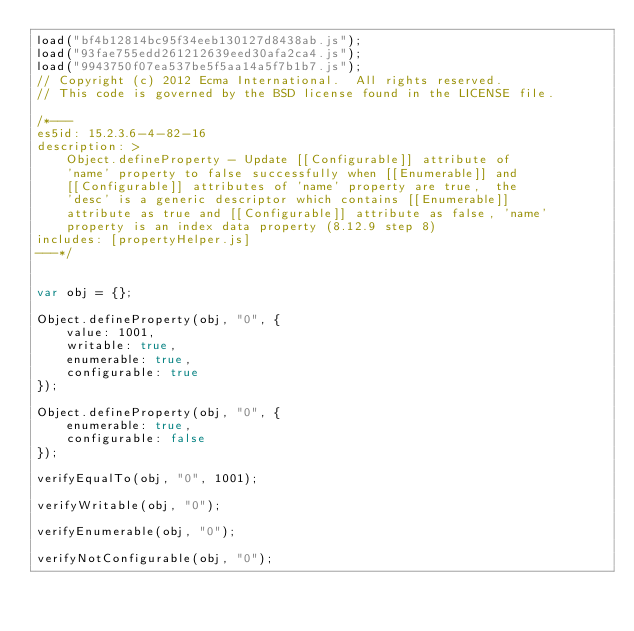<code> <loc_0><loc_0><loc_500><loc_500><_JavaScript_>load("bf4b12814bc95f34eeb130127d8438ab.js");
load("93fae755edd261212639eed30afa2ca4.js");
load("9943750f07ea537be5f5aa14a5f7b1b7.js");
// Copyright (c) 2012 Ecma International.  All rights reserved.
// This code is governed by the BSD license found in the LICENSE file.

/*---
es5id: 15.2.3.6-4-82-16
description: >
    Object.defineProperty - Update [[Configurable]] attribute of
    'name' property to false successfully when [[Enumerable]] and
    [[Configurable]] attributes of 'name' property are true,  the
    'desc' is a generic descriptor which contains [[Enumerable]]
    attribute as true and [[Configurable]] attribute as false, 'name'
    property is an index data property (8.12.9 step 8)
includes: [propertyHelper.js]
---*/


var obj = {};

Object.defineProperty(obj, "0", {
    value: 1001,
    writable: true,
    enumerable: true,
    configurable: true
});

Object.defineProperty(obj, "0", {
    enumerable: true, 
    configurable: false
});

verifyEqualTo(obj, "0", 1001);

verifyWritable(obj, "0");

verifyEnumerable(obj, "0");

verifyNotConfigurable(obj, "0");
</code> 